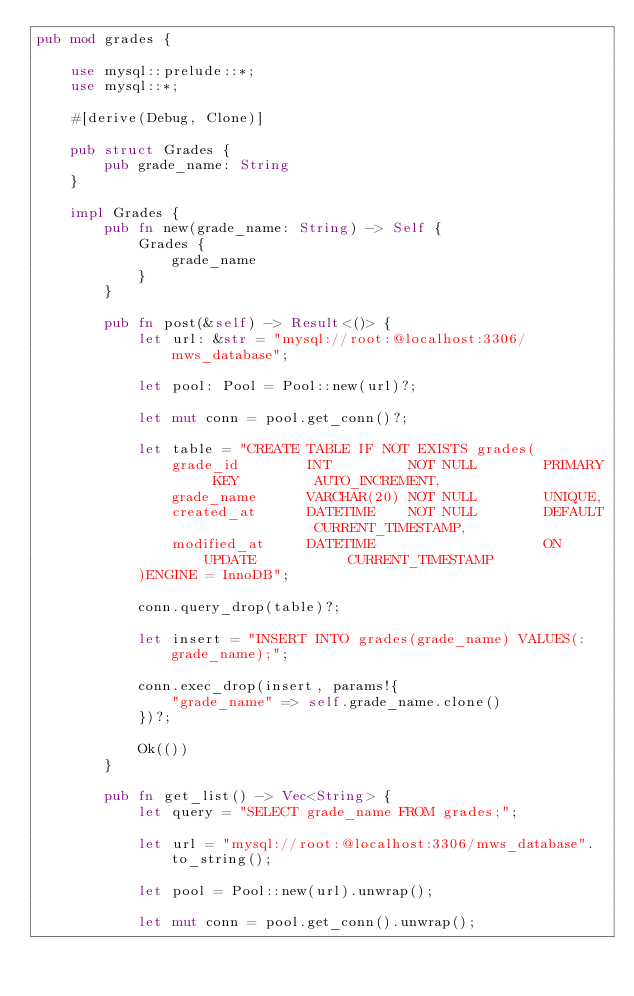Convert code to text. <code><loc_0><loc_0><loc_500><loc_500><_Rust_>pub mod grades {

    use mysql::prelude::*;
    use mysql::*;
    
    #[derive(Debug, Clone)]

    pub struct Grades {
        pub grade_name: String
    }

    impl Grades {
        pub fn new(grade_name: String) -> Self {
            Grades {
                grade_name
            }
        }

        pub fn post(&self) -> Result<()> {
            let url: &str = "mysql://root:@localhost:3306/mws_database";

            let pool: Pool = Pool::new(url)?;

            let mut conn = pool.get_conn()?;

            let table = "CREATE TABLE IF NOT EXISTS grades(
                grade_id        INT         NOT NULL        PRIMARY KEY         AUTO_INCREMENT,
                grade_name      VARCHAR(20) NOT NULL        UNIQUE,
                created_at      DATETIME    NOT NULL        DEFAULT             CURRENT_TIMESTAMP,
                modified_at     DATETIME                    ON UPDATE           CURRENT_TIMESTAMP
            )ENGINE = InnoDB";

            conn.query_drop(table)?;

            let insert = "INSERT INTO grades(grade_name) VALUES(:grade_name);";

            conn.exec_drop(insert, params!{
                "grade_name" => self.grade_name.clone()
            })?;

            Ok(())
        }

        pub fn get_list() -> Vec<String> {
            let query = "SELECT grade_name FROM grades;";

            let url = "mysql://root:@localhost:3306/mws_database".to_string();

            let pool = Pool::new(url).unwrap();

            let mut conn = pool.get_conn().unwrap();
</code> 